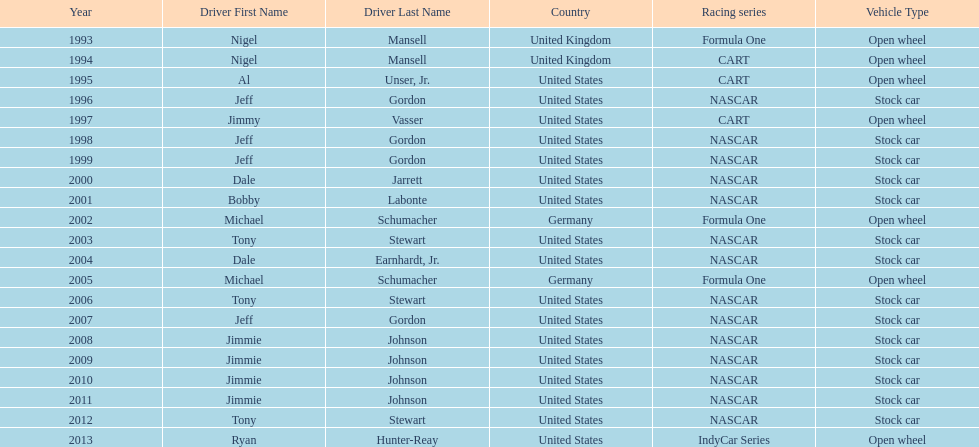How many total row entries are there? 21. 